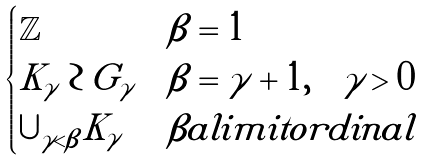Convert formula to latex. <formula><loc_0><loc_0><loc_500><loc_500>\begin{cases} \mathbb { Z } & \beta = 1 \\ K _ { \gamma } \wr G _ { \gamma } & \beta = \gamma + 1 , \quad \gamma > 0 \\ \cup _ { \gamma < \beta } K _ { \gamma } & \beta a l i m i t o r d i n a l \end{cases}</formula> 